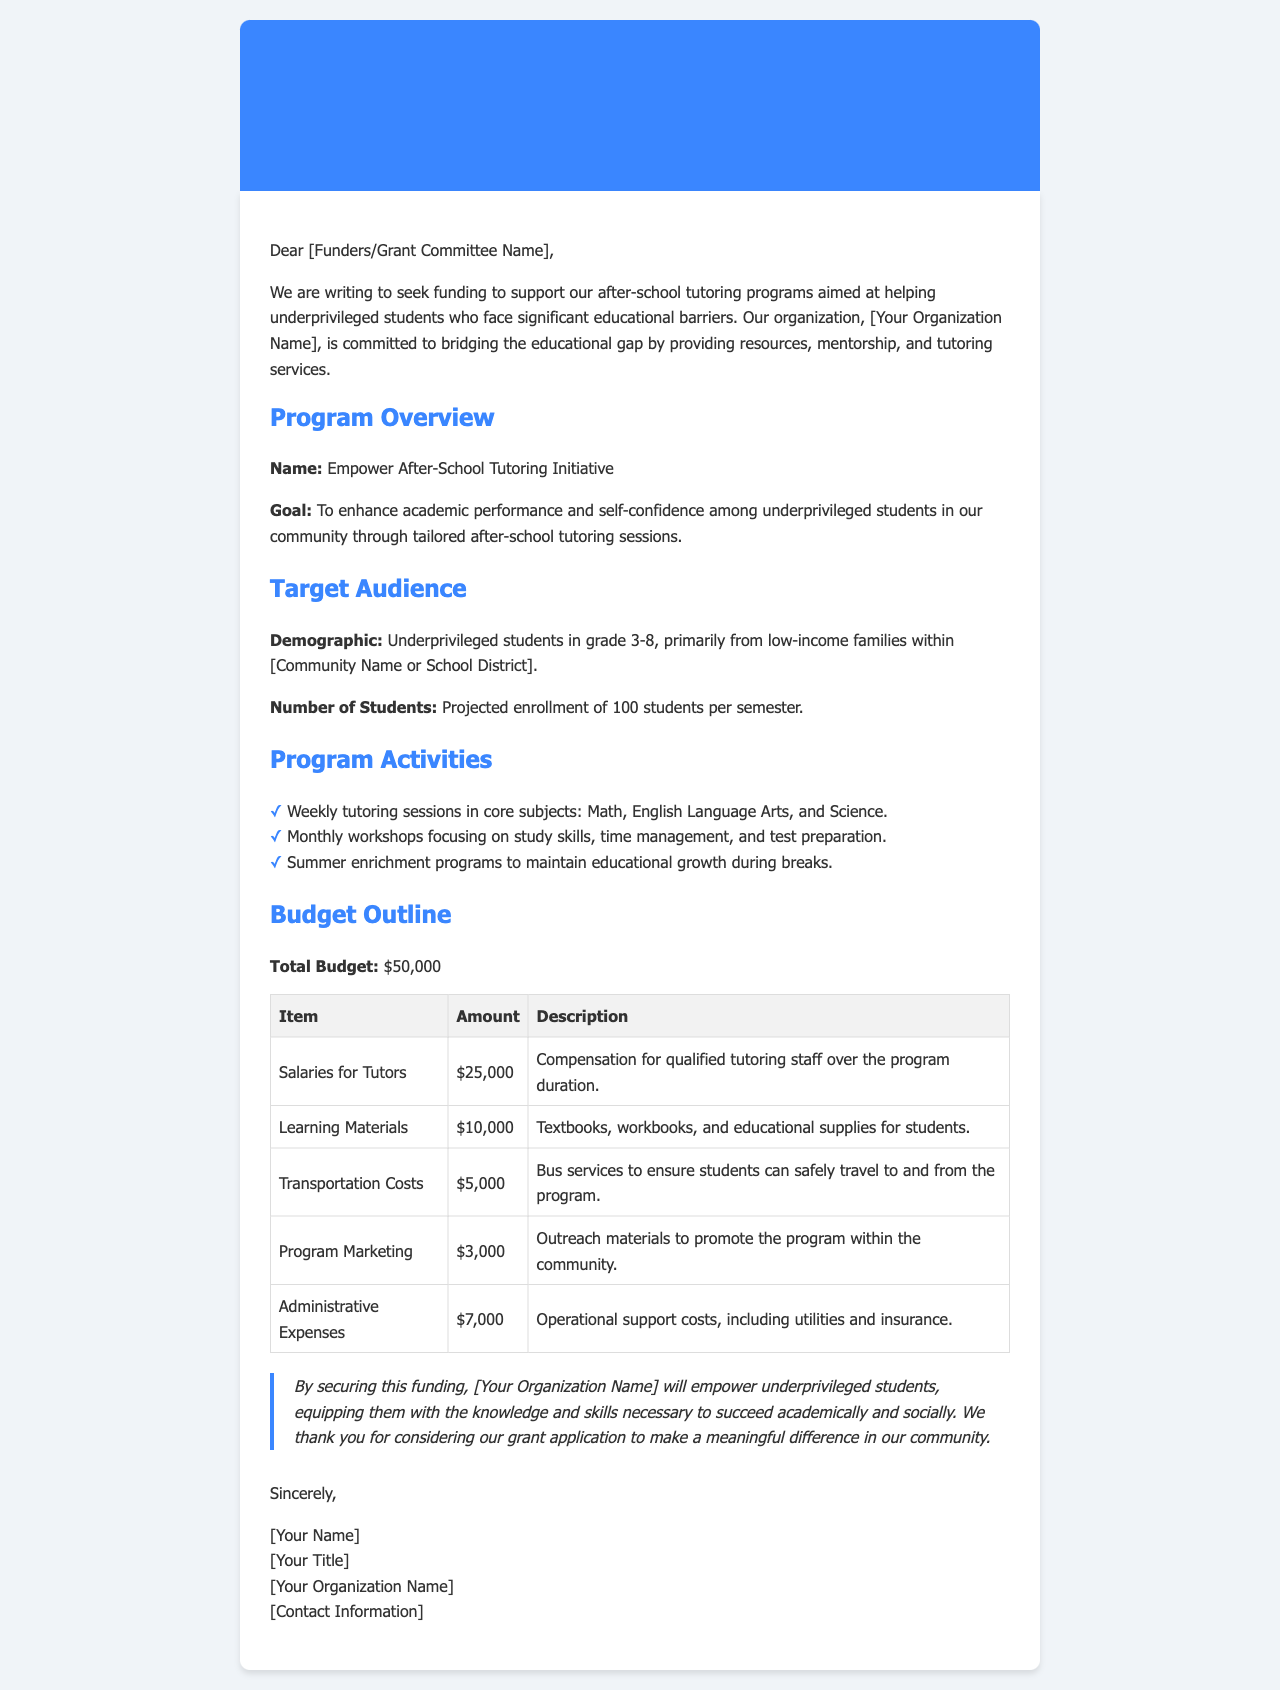what is the total budget for the program? The total budget is outlined in the document as $50,000.
Answer: $50,000 how many students are projected to enroll per semester? The document states a projected enrollment of 100 students per semester.
Answer: 100 students what is the name of the initiative? The initiative is named "Empower After-School Tutoring Initiative."
Answer: Empower After-School Tutoring Initiative how much is allocated for salaries for tutors? The budget outline specifies $25,000 allocated for salaries for tutors.
Answer: $25,000 what type of programs are included in the program activities? The document mentions weekly tutoring sessions, monthly workshops, and summer enrichment programs.
Answer: Weekly tutoring sessions, monthly workshops, summer enrichment programs what is the goal of the initiative? The goal of the initiative is to enhance academic performance and self-confidence among underprivileged students.
Answer: Enhance academic performance and self-confidence how much funding is needed for transportation costs? The budget states that $5,000 is needed for transportation costs.
Answer: $5,000 who is the target audience? The target audience is underprivileged students in grade 3-8.
Answer: Underprivileged students in grade 3-8 what is included in the learning materials budget? The learning materials budget accounts for textbooks, workbooks, and educational supplies for students.
Answer: Textbooks, workbooks, and educational supplies 